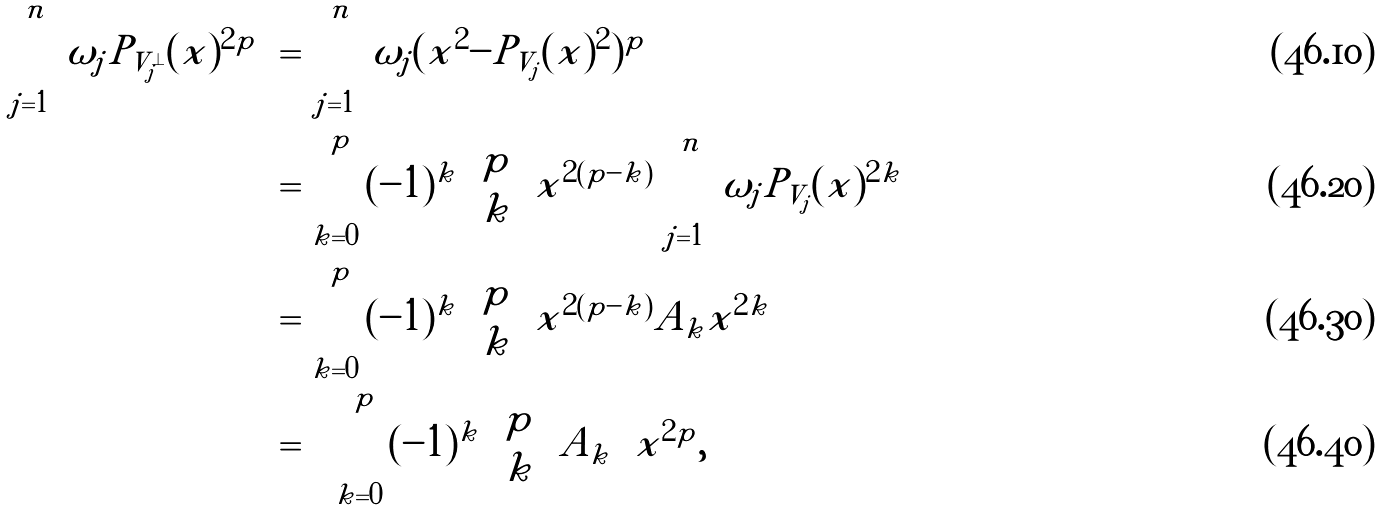<formula> <loc_0><loc_0><loc_500><loc_500>\sum _ { j = 1 } ^ { n } \omega _ { j } \| P _ { V _ { j } ^ { \perp } } ( x ) \| ^ { 2 p } & = \sum _ { j = 1 } ^ { n } \omega _ { j } ( \| x \| ^ { 2 } - \| P _ { V _ { j } } ( x ) \| ^ { 2 } ) ^ { p } \\ & = \sum _ { k = 0 } ^ { p } ( - 1 ) ^ { k } \binom { p } { k } \| x \| ^ { 2 ( p - k ) } \sum _ { j = 1 } ^ { n } \omega _ { j } \| P _ { V _ { j } } ( x ) \| ^ { 2 k } \\ & = \sum _ { k = 0 } ^ { p } ( - 1 ) ^ { k } \binom { p } { k } \| x \| ^ { 2 ( p - k ) } A _ { k } \| x \| ^ { 2 k } \\ & = \left ( \sum _ { k = 0 } ^ { p } ( - 1 ) ^ { k } \binom { p } { k } A _ { k } \right ) \| x \| ^ { 2 p } ,</formula> 